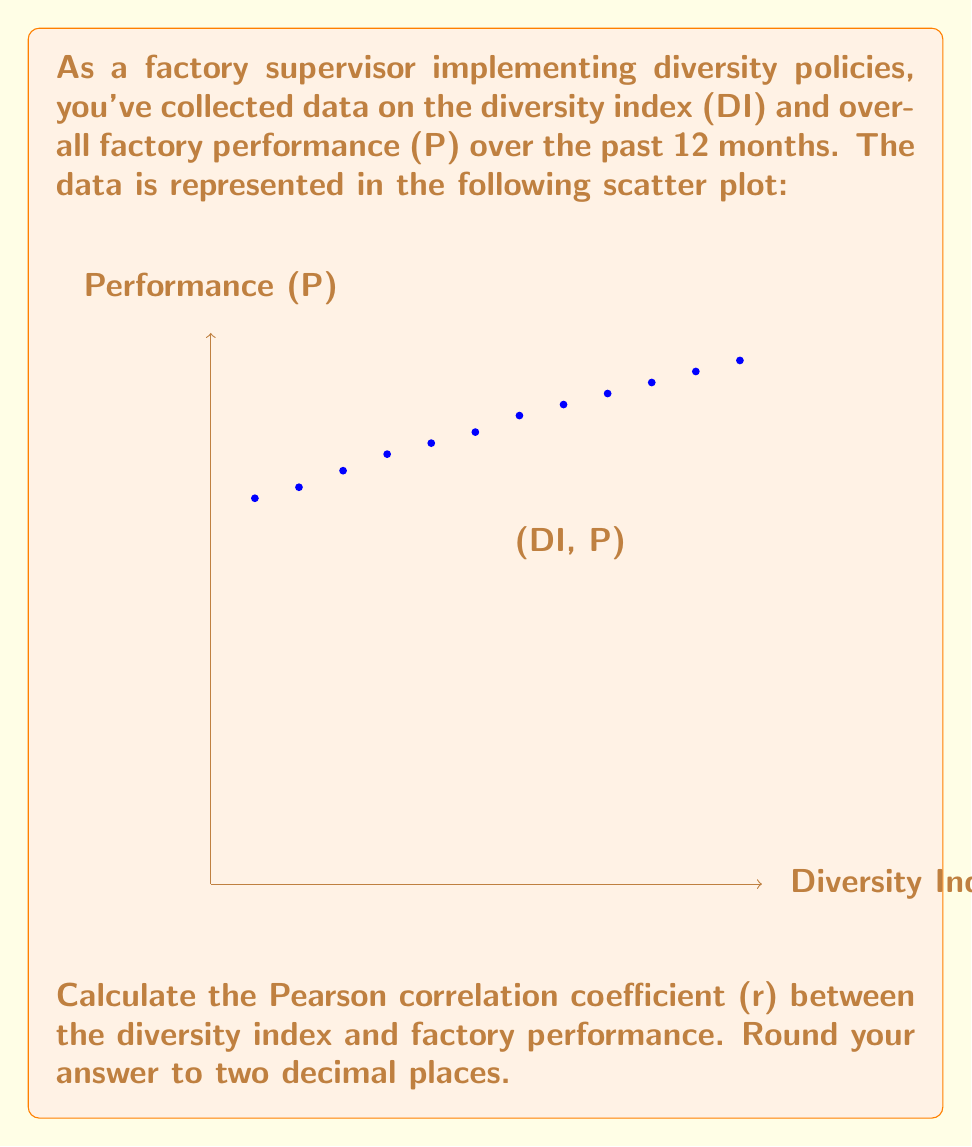Teach me how to tackle this problem. To calculate the Pearson correlation coefficient (r), we'll use the formula:

$$ r = \frac{n\sum xy - \sum x \sum y}{\sqrt{[n\sum x^2 - (\sum x)^2][n\sum y^2 - (\sum y)^2]}} $$

Where:
n = number of data points
x = Diversity Index (DI)
y = Performance (P)

Step 1: Calculate the required sums:
n = 12
$\sum x = 6.25$
$\sum y = 967$
$\sum xy = 516.85$
$\sum x^2 = 3.4875$
$\sum y^2 = 79,015$

Step 2: Substitute these values into the formula:

$$ r = \frac{12(516.85) - (6.25)(967)}{\sqrt{[12(3.4875) - (6.25)^2][12(79,015) - (967)^2]}} $$

Step 3: Solve the equation:

$$ r = \frac{6202.2 - 6043.75}{\sqrt{(41.85 - 39.0625)(948180 - 935089)}} $$

$$ r = \frac{158.45}{\sqrt{2.7875 * 13091}} $$

$$ r = \frac{158.45}{\sqrt{36491.4125}} $$

$$ r = \frac{158.45}{191.03} $$

$$ r = 0.8294 $$

Step 4: Round to two decimal places:

r ≈ 0.83
Answer: 0.83 